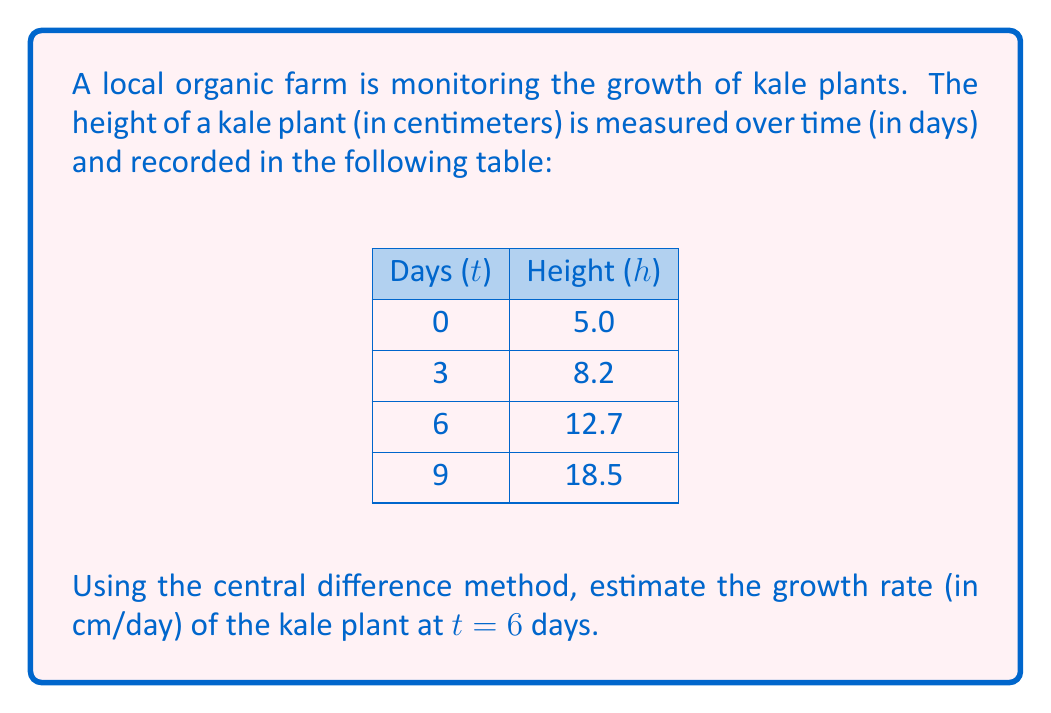Can you answer this question? To estimate the growth rate at t = 6 days using the central difference method, we'll follow these steps:

1) The central difference formula for the first derivative (growth rate) is:

   $$f'(x) \approx \frac{f(x+h) - f(x-h)}{2h}$$

   where h is the step size.

2) In our case, x = 6 days, and h = 3 days (the interval between measurements).

3) We need to identify f(x+h) and f(x-h):
   f(x+h) = f(9) = 18.5 cm
   f(x-h) = f(3) = 8.2 cm

4) Plugging these values into the central difference formula:

   $$f'(6) \approx \frac{f(9) - f(3)}{2(3)} = \frac{18.5 - 8.2}{6}$$

5) Calculating the result:

   $$f'(6) \approx \frac{10.3}{6} \approx 1.7167$$

Therefore, the estimated growth rate of the kale plant at t = 6 days is approximately 1.72 cm/day.
Answer: 1.72 cm/day 